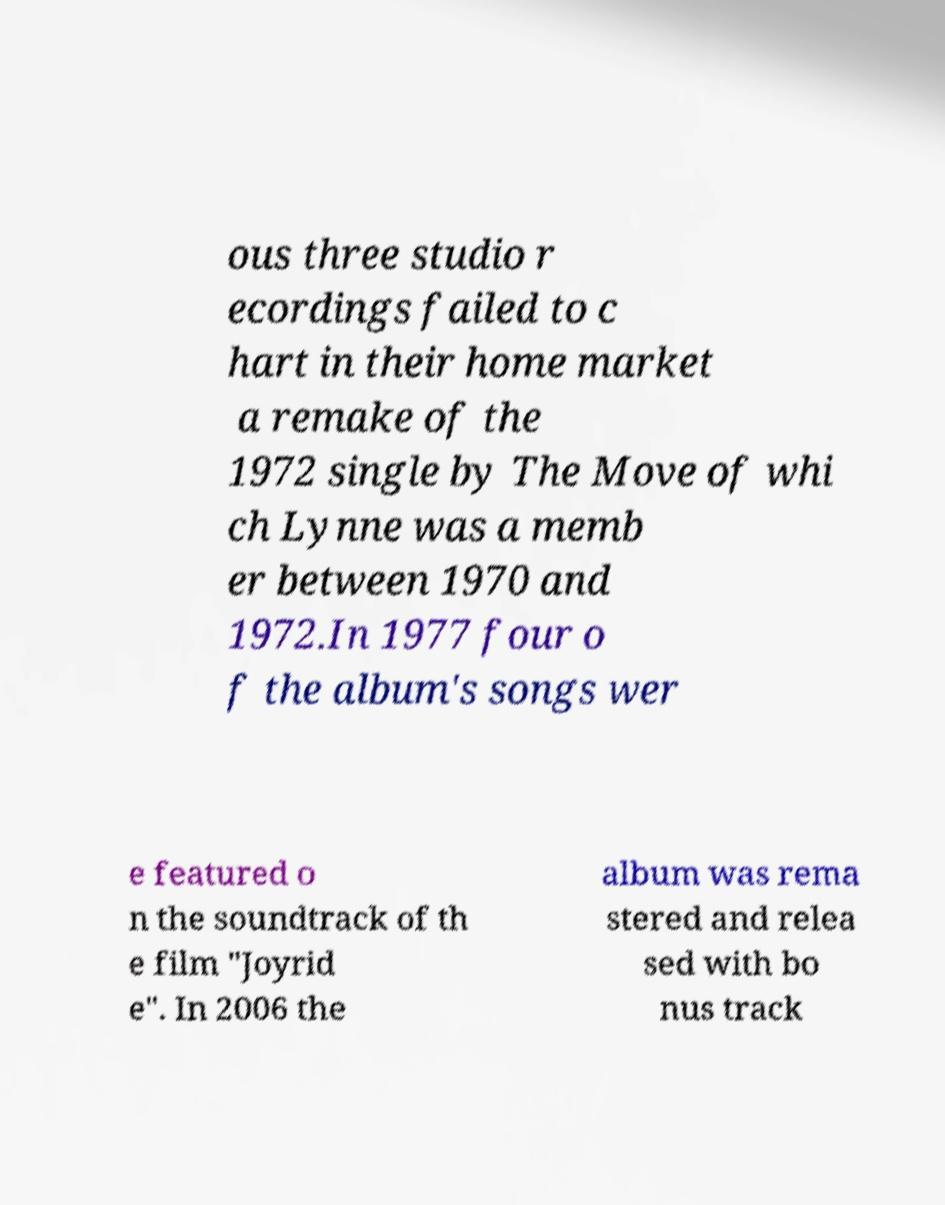What messages or text are displayed in this image? I need them in a readable, typed format. ous three studio r ecordings failed to c hart in their home market a remake of the 1972 single by The Move of whi ch Lynne was a memb er between 1970 and 1972.In 1977 four o f the album's songs wer e featured o n the soundtrack of th e film "Joyrid e". In 2006 the album was rema stered and relea sed with bo nus track 